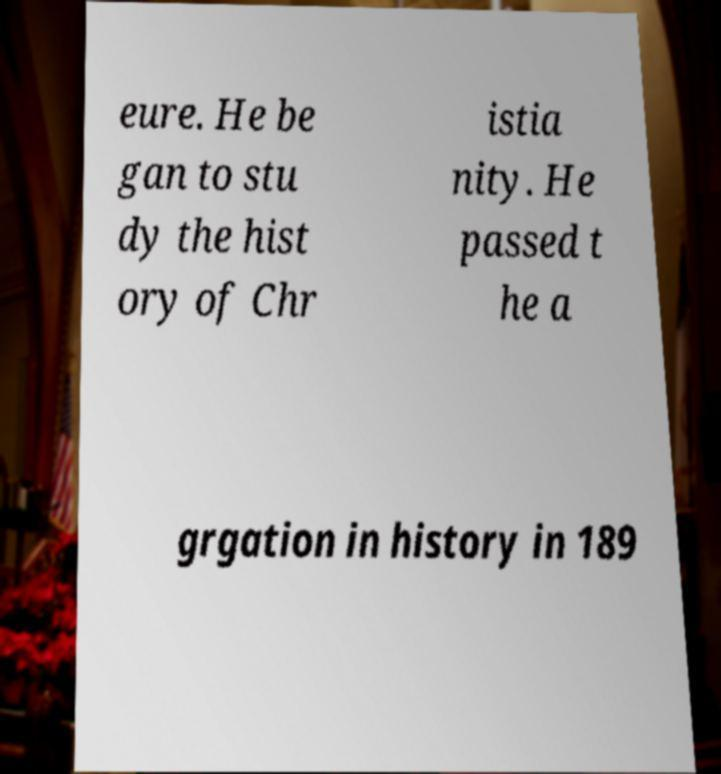Can you read and provide the text displayed in the image?This photo seems to have some interesting text. Can you extract and type it out for me? eure. He be gan to stu dy the hist ory of Chr istia nity. He passed t he a grgation in history in 189 